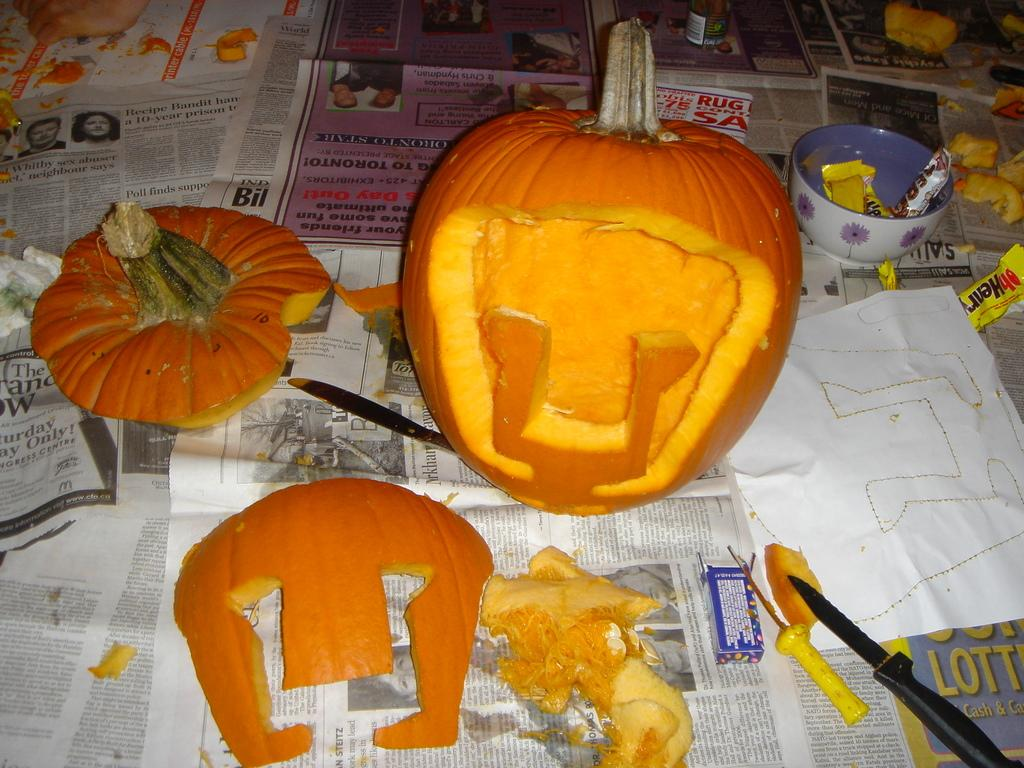What type of food is featured in the image? There are sliced pumpkins in the image. What utensils are present in the image? There are knives in the image. What is used for holding or serving in the image? There is a bowl in the image. What is written or drawn on the paper in the image? There are objects on a paper in the image. How many girls are wearing sweaters in the image? There are no girls or sweaters present in the image. What type of pin can be seen holding the paper in the image? There is no pin visible in the image; the paper is not held by any pin. 